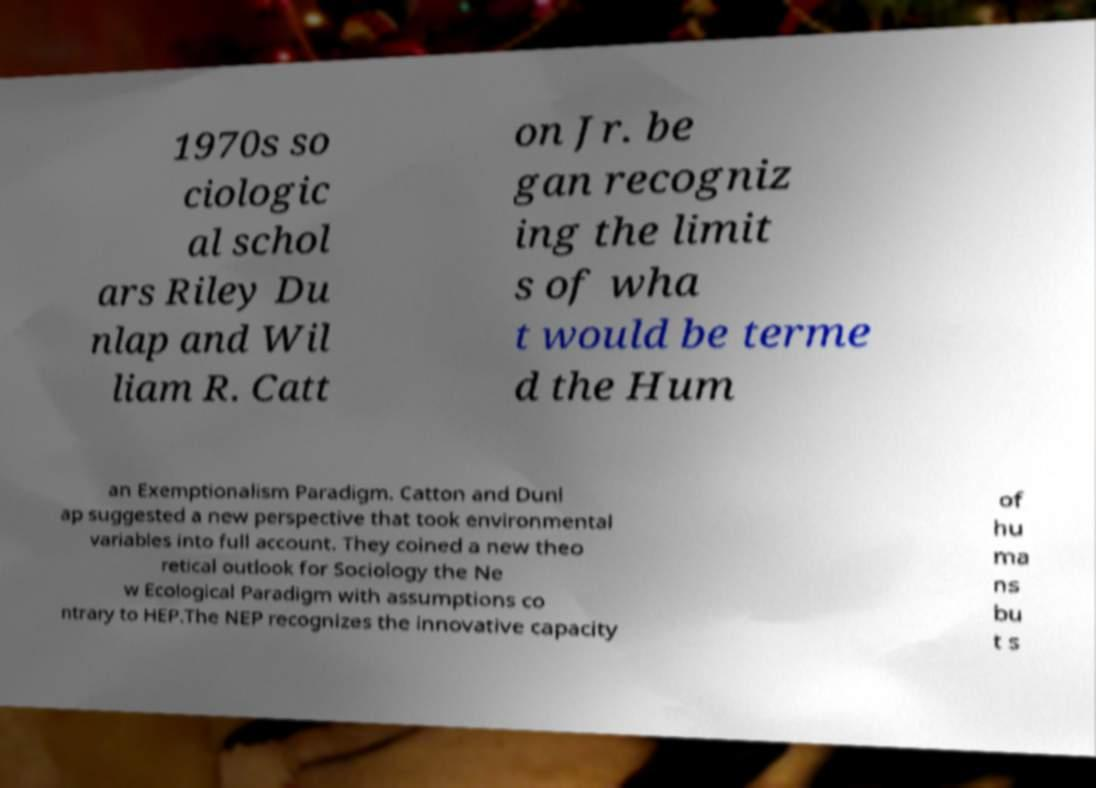I need the written content from this picture converted into text. Can you do that? 1970s so ciologic al schol ars Riley Du nlap and Wil liam R. Catt on Jr. be gan recogniz ing the limit s of wha t would be terme d the Hum an Exemptionalism Paradigm. Catton and Dunl ap suggested a new perspective that took environmental variables into full account. They coined a new theo retical outlook for Sociology the Ne w Ecological Paradigm with assumptions co ntrary to HEP.The NEP recognizes the innovative capacity of hu ma ns bu t s 